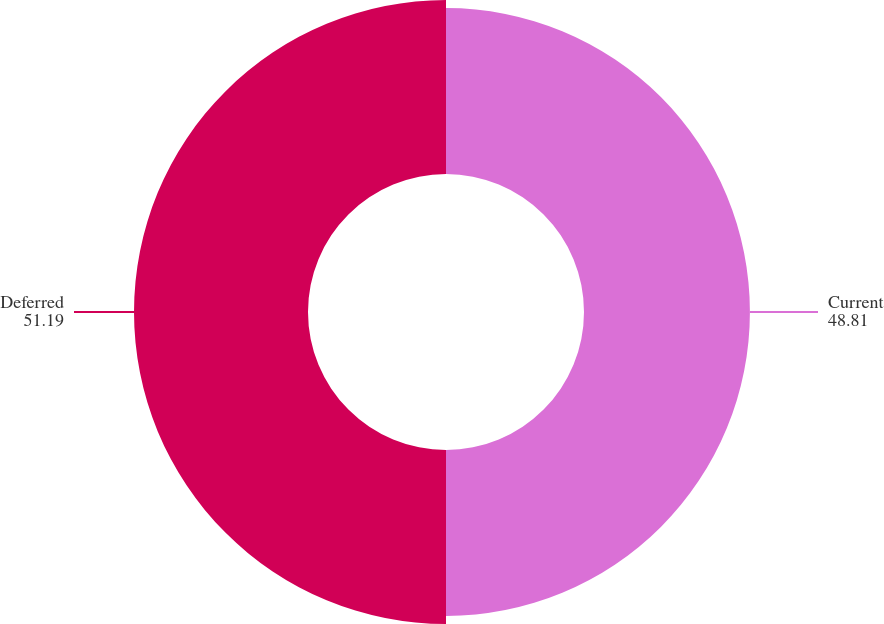Convert chart. <chart><loc_0><loc_0><loc_500><loc_500><pie_chart><fcel>Current<fcel>Deferred<nl><fcel>48.81%<fcel>51.19%<nl></chart> 